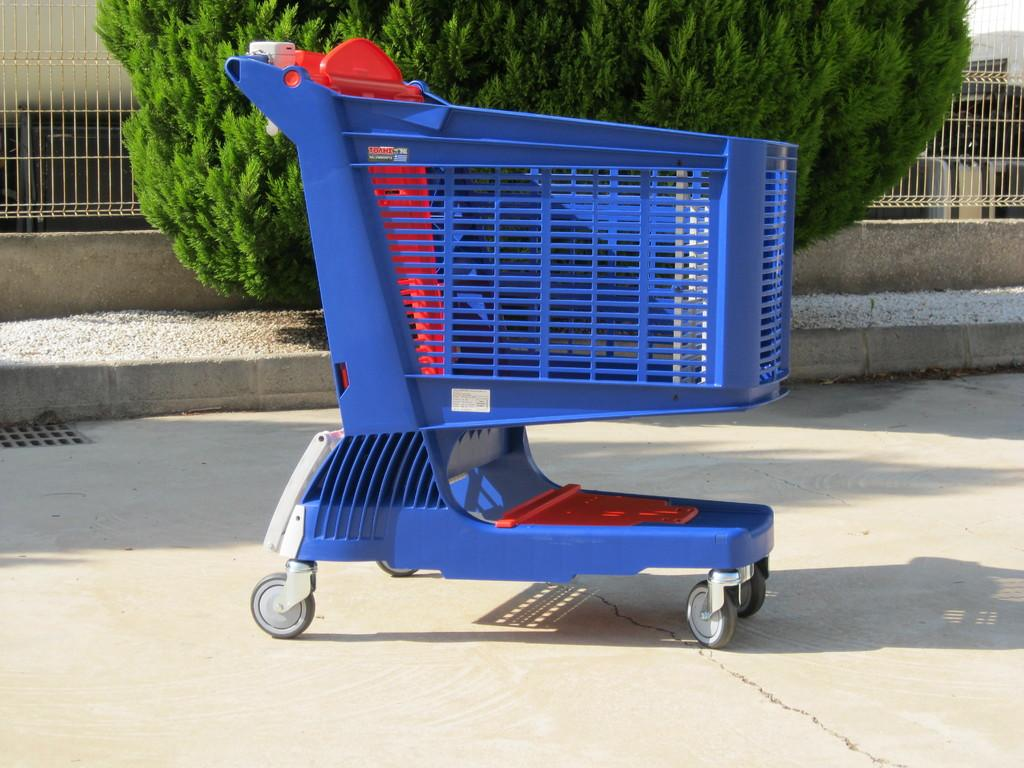What object is on the ground in the image? There is a trolley on the ground in the image. What can be seen in the distance in the image? There is a tree in the background of the image. What architectural feature is visible in the background of the image? There is railing on the wall in the background of the image. What type of mine is visible in the image? There is no mine present in the image. What territory does the tree in the image belong to? The image does not provide information about the territory of the tree. 